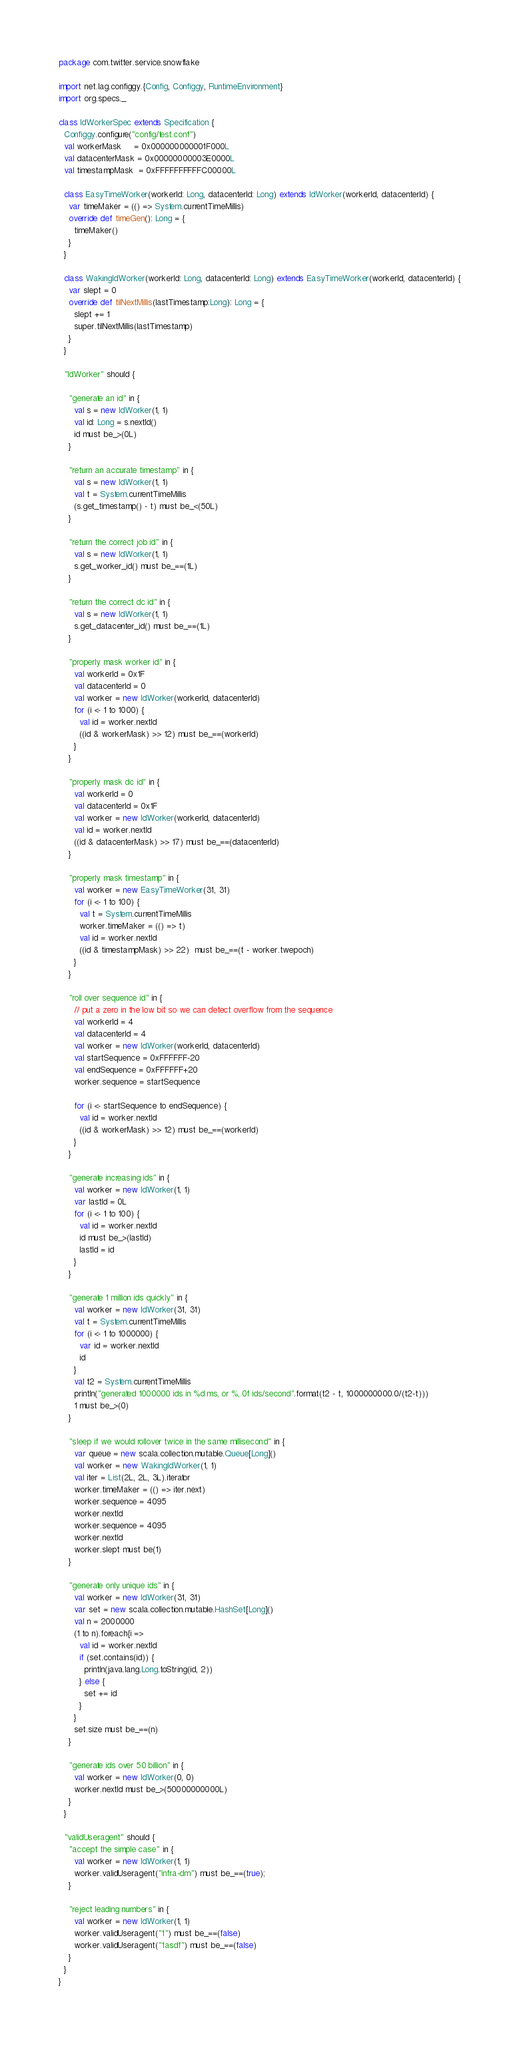Convert code to text. <code><loc_0><loc_0><loc_500><loc_500><_Scala_>package com.twitter.service.snowflake

import net.lag.configgy.{Config, Configgy, RuntimeEnvironment}
import org.specs._

class IdWorkerSpec extends Specification {
  Configgy.configure("config/test.conf")
  val workerMask     = 0x000000000001F000L
  val datacenterMask = 0x00000000003E0000L
  val timestampMask  = 0xFFFFFFFFFFC00000L

  class EasyTimeWorker(workerId: Long, datacenterId: Long) extends IdWorker(workerId, datacenterId) {
    var timeMaker = (() => System.currentTimeMillis)
    override def timeGen(): Long = {
      timeMaker()
    }
  }

  class WakingIdWorker(workerId: Long, datacenterId: Long) extends EasyTimeWorker(workerId, datacenterId) {
    var slept = 0
    override def tilNextMillis(lastTimestamp:Long): Long = {
      slept += 1
      super.tilNextMillis(lastTimestamp)
    }
  }

  "IdWorker" should {

    "generate an id" in {
      val s = new IdWorker(1, 1)
      val id: Long = s.nextId()
      id must be_>(0L)
    }

    "return an accurate timestamp" in {
      val s = new IdWorker(1, 1)
      val t = System.currentTimeMillis
      (s.get_timestamp() - t) must be_<(50L)
    }

    "return the correct job id" in {
      val s = new IdWorker(1, 1)
      s.get_worker_id() must be_==(1L)
    }

    "return the correct dc id" in {
      val s = new IdWorker(1, 1)
      s.get_datacenter_id() must be_==(1L)
    }

    "properly mask worker id" in {
      val workerId = 0x1F
      val datacenterId = 0
      val worker = new IdWorker(workerId, datacenterId)
      for (i <- 1 to 1000) {
        val id = worker.nextId
        ((id & workerMask) >> 12) must be_==(workerId)
      }
    }

    "properly mask dc id" in {
      val workerId = 0
      val datacenterId = 0x1F
      val worker = new IdWorker(workerId, datacenterId)
      val id = worker.nextId
      ((id & datacenterMask) >> 17) must be_==(datacenterId)
    }

    "properly mask timestamp" in {
      val worker = new EasyTimeWorker(31, 31)
      for (i <- 1 to 100) {
        val t = System.currentTimeMillis
        worker.timeMaker = (() => t)
        val id = worker.nextId
        ((id & timestampMask) >> 22)  must be_==(t - worker.twepoch)
      }
    }

    "roll over sequence id" in {
      // put a zero in the low bit so we can detect overflow from the sequence
      val workerId = 4
      val datacenterId = 4
      val worker = new IdWorker(workerId, datacenterId)
      val startSequence = 0xFFFFFF-20
      val endSequence = 0xFFFFFF+20
      worker.sequence = startSequence

      for (i <- startSequence to endSequence) {
        val id = worker.nextId
        ((id & workerMask) >> 12) must be_==(workerId)
      }
    }

    "generate increasing ids" in {
      val worker = new IdWorker(1, 1)
      var lastId = 0L
      for (i <- 1 to 100) {
        val id = worker.nextId
        id must be_>(lastId)
        lastId = id
      }
    }

    "generate 1 million ids quickly" in {
      val worker = new IdWorker(31, 31)
      val t = System.currentTimeMillis
      for (i <- 1 to 1000000) {
        var id = worker.nextId
        id
      }
      val t2 = System.currentTimeMillis
      println("generated 1000000 ids in %d ms, or %,.0f ids/second".format(t2 - t, 1000000000.0/(t2-t)))
      1 must be_>(0)
    }

    "sleep if we would rollover twice in the same millisecond" in {
      var queue = new scala.collection.mutable.Queue[Long]()
      val worker = new WakingIdWorker(1, 1)
      val iter = List(2L, 2L, 3L).iterator
      worker.timeMaker = (() => iter.next)
      worker.sequence = 4095
      worker.nextId
      worker.sequence = 4095
      worker.nextId
      worker.slept must be(1)
    }

    "generate only unique ids" in {
      val worker = new IdWorker(31, 31)
      var set = new scala.collection.mutable.HashSet[Long]()
      val n = 2000000
      (1 to n).foreach{i =>
        val id = worker.nextId
        if (set.contains(id)) {
          println(java.lang.Long.toString(id, 2))
        } else {
          set += id
        }
      }
      set.size must be_==(n)
    }

    "generate ids over 50 billion" in {
      val worker = new IdWorker(0, 0)
      worker.nextId must be_>(50000000000L)
    }
  }

  "validUseragent" should {
    "accept the simple case" in {
      val worker = new IdWorker(1, 1)
      worker.validUseragent("infra-dm") must be_==(true);
    }

    "reject leading numbers" in {
      val worker = new IdWorker(1, 1)
      worker.validUseragent("1") must be_==(false)
      worker.validUseragent("1asdf") must be_==(false)
    }
  }
}
</code> 